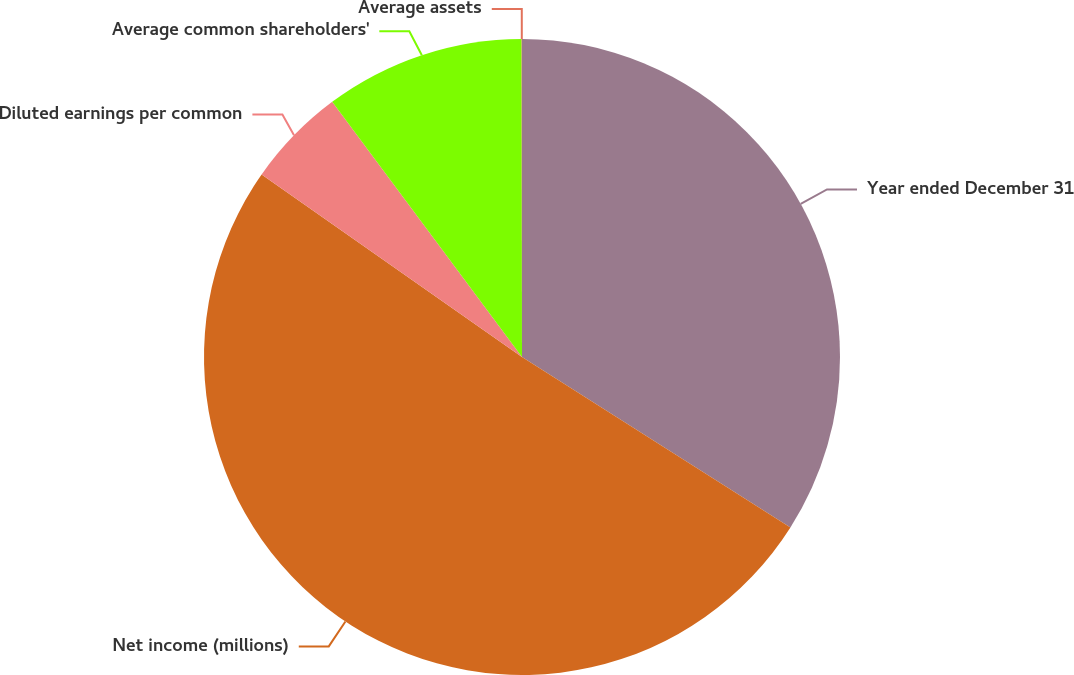Convert chart. <chart><loc_0><loc_0><loc_500><loc_500><pie_chart><fcel>Year ended December 31<fcel>Net income (millions)<fcel>Diluted earnings per common<fcel>Average common shareholders'<fcel>Average assets<nl><fcel>34.01%<fcel>50.73%<fcel>5.09%<fcel>10.16%<fcel>0.02%<nl></chart> 